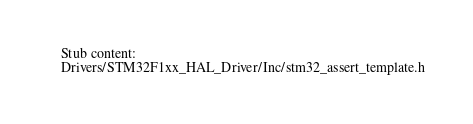<code> <loc_0><loc_0><loc_500><loc_500><_C_>Stub content:
Drivers/STM32F1xx_HAL_Driver/Inc/stm32_assert_template.h
</code> 